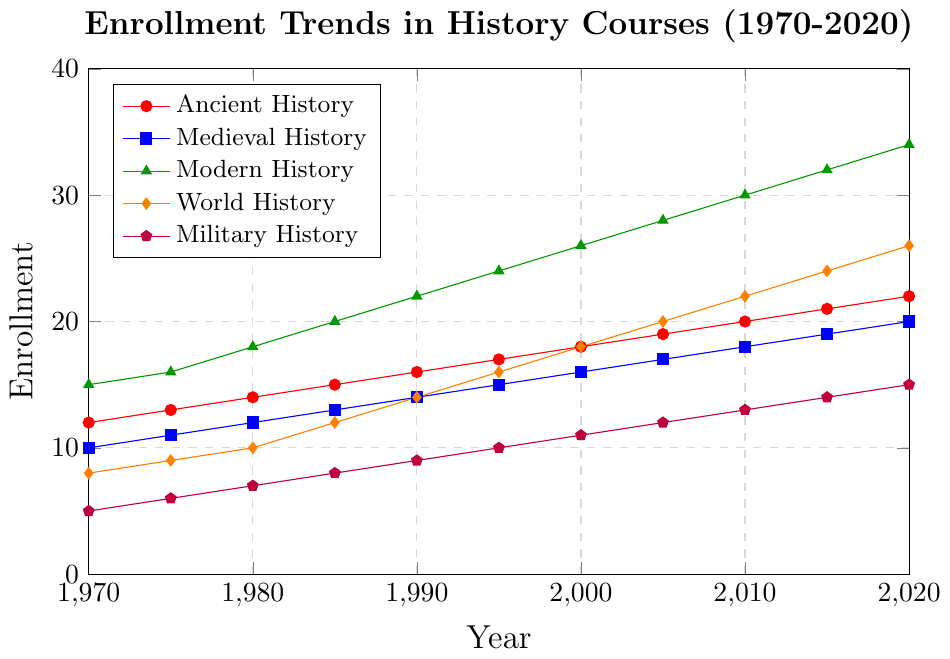Which history specialization had the highest enrollment in 2020? From the figure, locate the enrollment values for each history specialization in 2020. Compare them to identify the highest value. Modern History had the highest enrollment at 34.
Answer: Modern History What was the increase in enrollment for Military History from 1970 to 2020? Check the enrollment for Military History in 1970 and 2020. Subtract the 1970 value from the 2020 value: 15 - 5 = 10.
Answer: 10 Which specializations had an equal enrollment in 1980 and what was that value? Look at the enrollment values for all specializations in 1980. Identify any specializations with the same values. Both Medieval History and World History had enrollments of 10.
Answer: Medieval History, World History; 10 What is the average enrollment for Ancient History across all years presented? Sum the enrollment values for Ancient History across all years and divide by the number of years: (12 + 13 + 14 + 15 + 16 + 17 + 18 + 19 + 20 + 21 + 22) / 11 = 17.
Answer: 17 Which specialization showed the least growth from 1970 to 2020? Calculate the increase in enrollment for each specialization from 1970 to 2020. Compare the differences to find the smallest: Ancient History increased by 10, Medieval History by 10, Modern History by 19, World History by 18, and Military History by 10. The least growth was shown by Ancient, Medieval, and Military History.
Answer: Ancient History, Medieval History, Military History Is the enrollment trend for Modern History different from the trend for World History? If so, how? Compare the enrollment trends for Modern History and World History over the years. Modern History shows a steady, higher-scaled increase, whereas World History also increases but starts and remains lower in comparison. Modern History trends upward more sharply.
Answer: Yes; Modern History trends upward more sharply In which year did World History enrollment first reach double figures? Examine the enrollment values for World History each year to see when it first reaches 10 or higher. It reached 10 in 1980.
Answer: 1980 What was the combined enrollment for all specializations in the year 1995? Sum the enrollments of all five specializations for the year 1995: 17 (Ancient History) + 15 (Medieval History) + 24 (Modern History) + 16 (World History) + 10 (Military History) = 82.
Answer: 82 